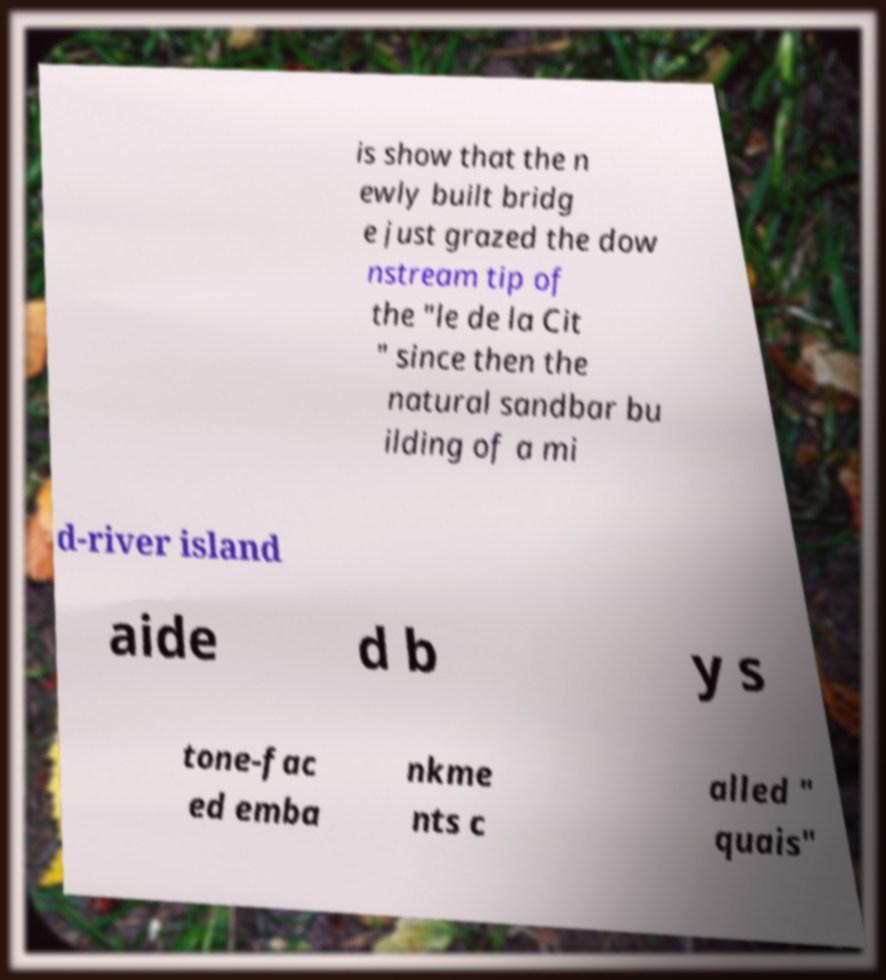Can you read and provide the text displayed in the image?This photo seems to have some interesting text. Can you extract and type it out for me? is show that the n ewly built bridg e just grazed the dow nstream tip of the "le de la Cit " since then the natural sandbar bu ilding of a mi d-river island aide d b y s tone-fac ed emba nkme nts c alled " quais" 